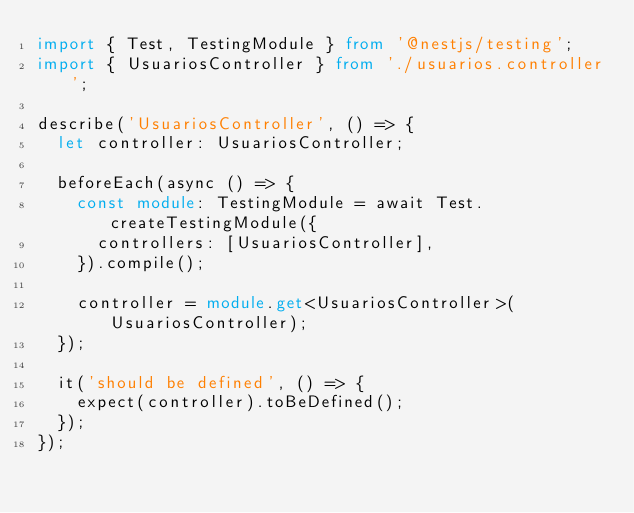Convert code to text. <code><loc_0><loc_0><loc_500><loc_500><_TypeScript_>import { Test, TestingModule } from '@nestjs/testing';
import { UsuariosController } from './usuarios.controller';

describe('UsuariosController', () => {
  let controller: UsuariosController;

  beforeEach(async () => {
    const module: TestingModule = await Test.createTestingModule({
      controllers: [UsuariosController],
    }).compile();

    controller = module.get<UsuariosController>(UsuariosController);
  });

  it('should be defined', () => {
    expect(controller).toBeDefined();
  });
});</code> 